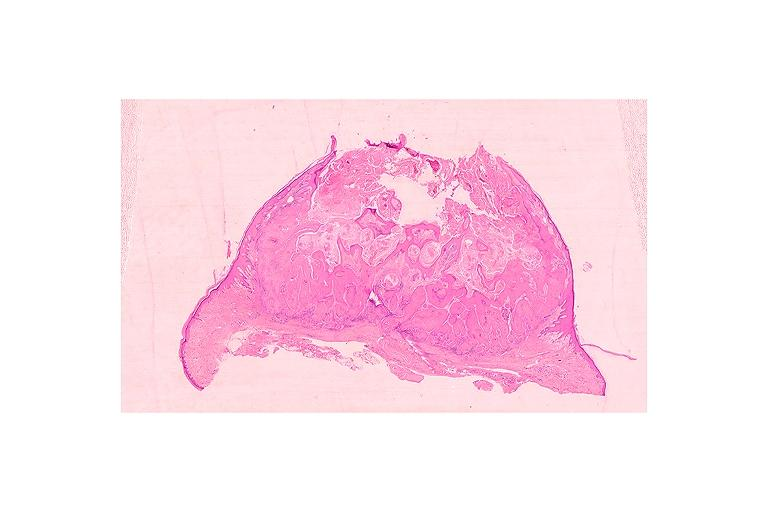where is this?
Answer the question using a single word or phrase. Oral 